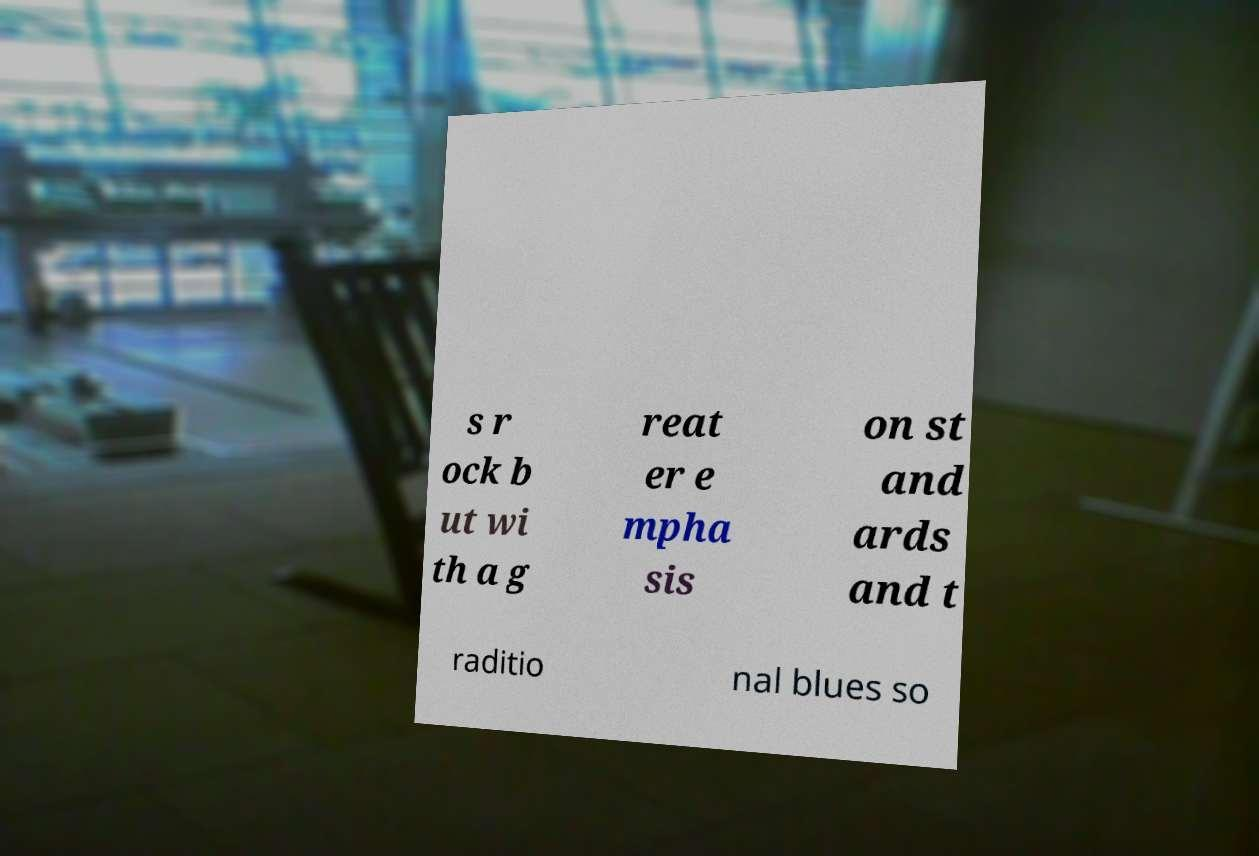Please identify and transcribe the text found in this image. s r ock b ut wi th a g reat er e mpha sis on st and ards and t raditio nal blues so 